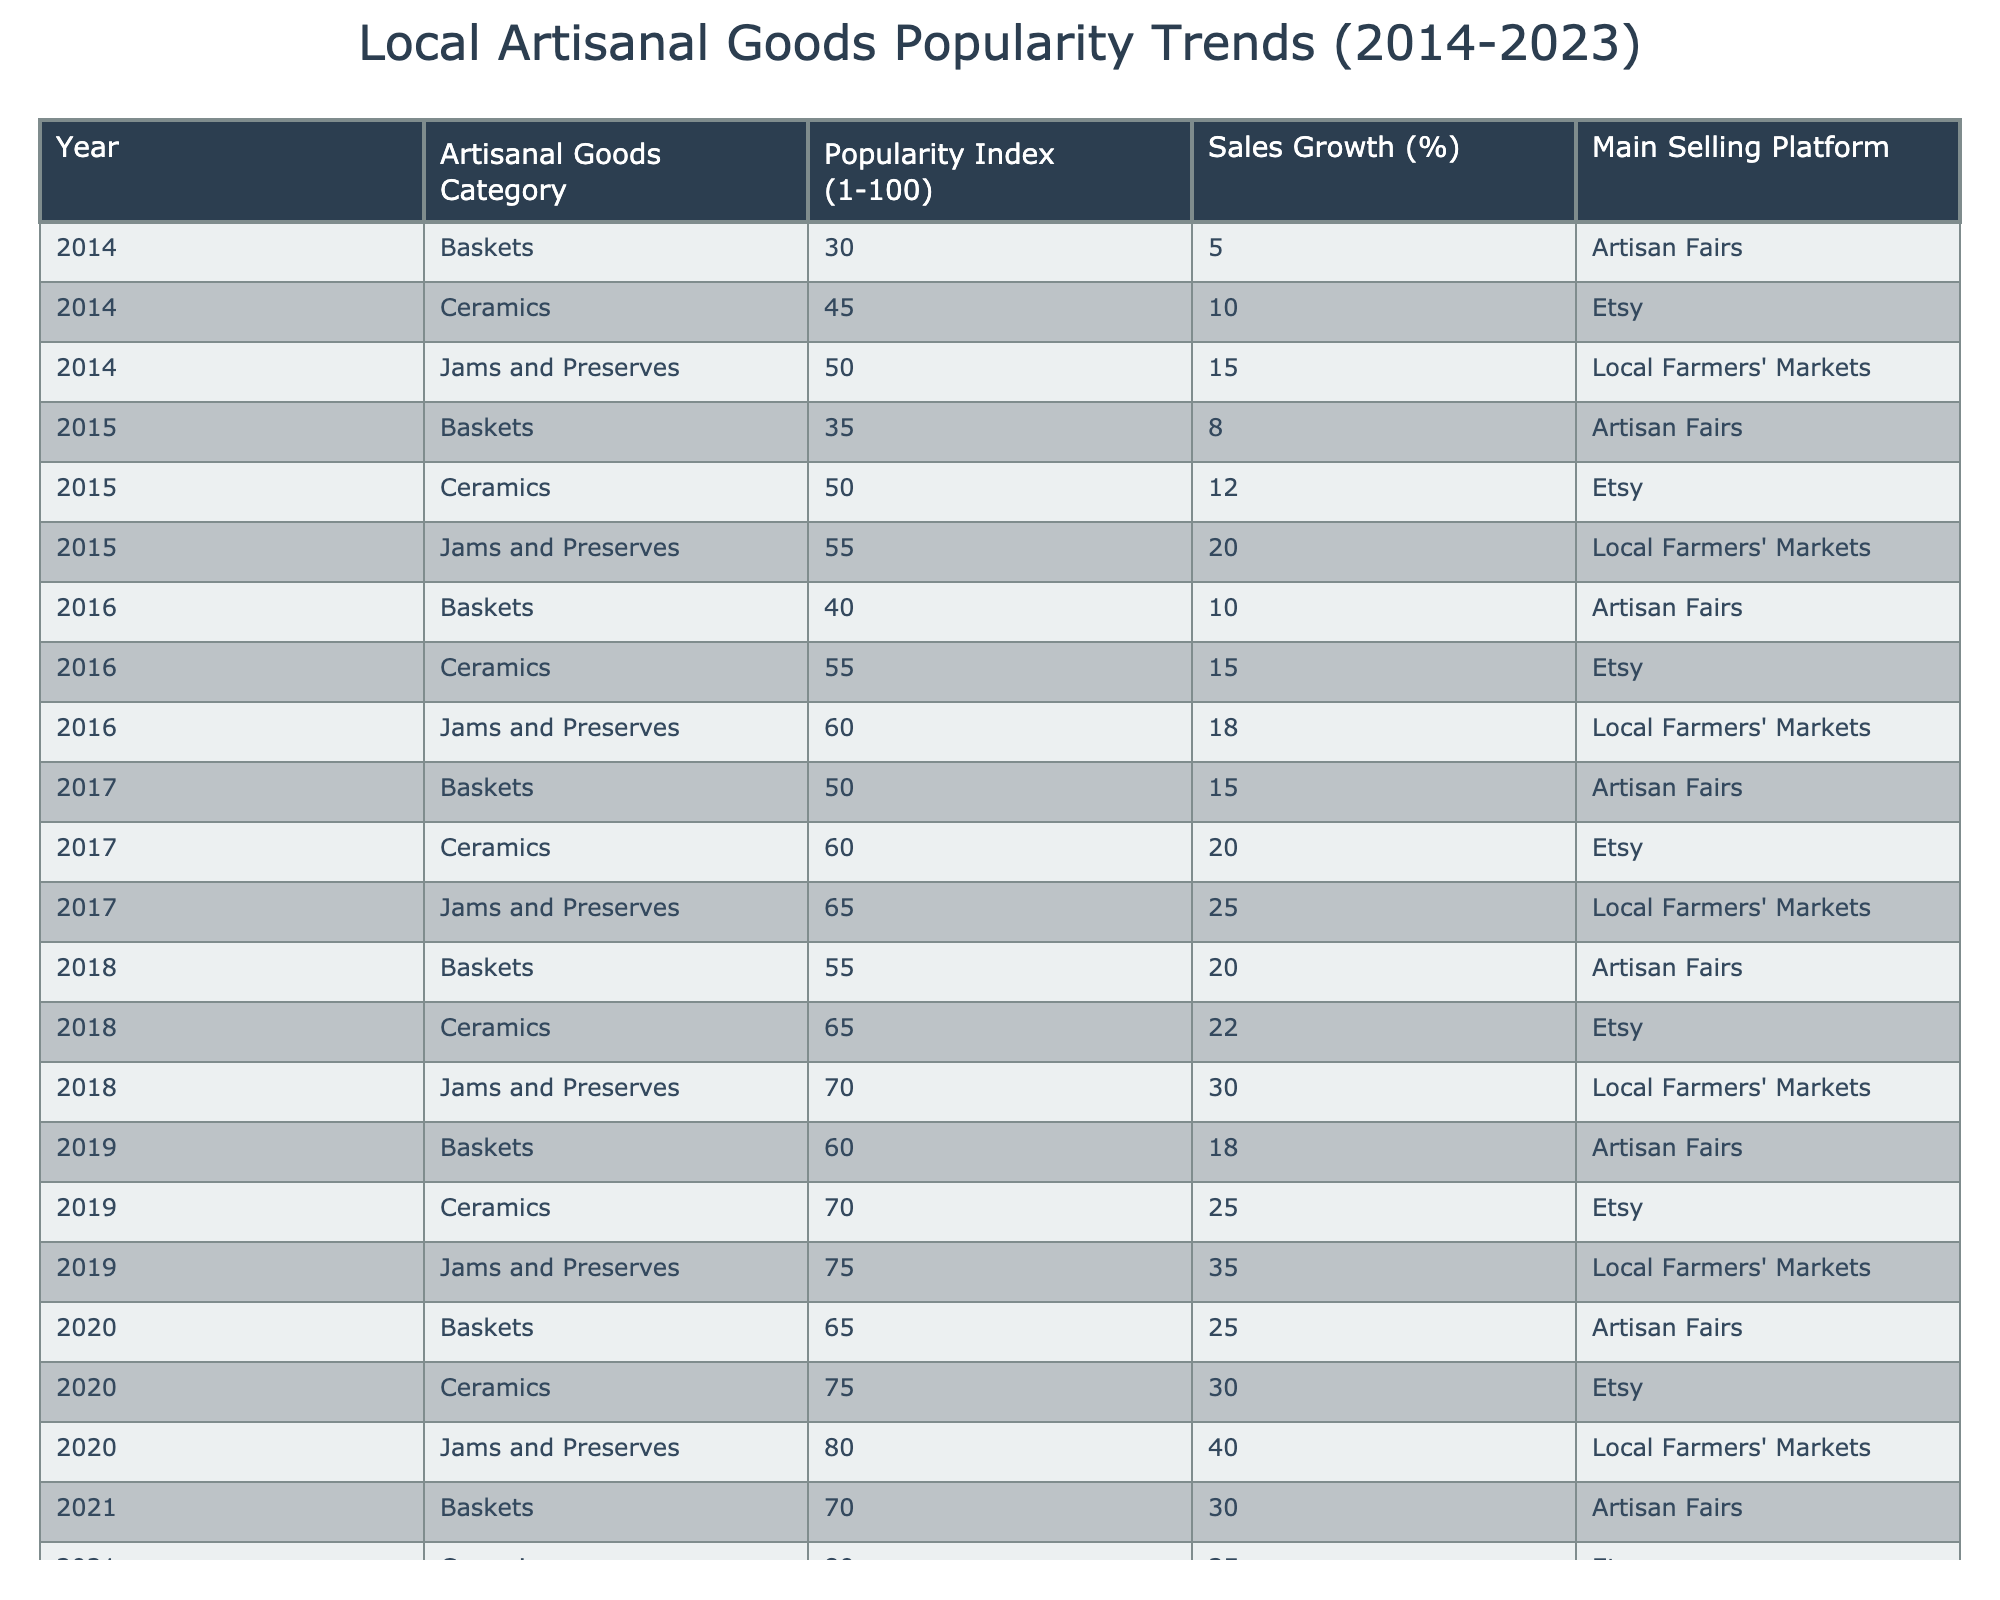What was the popularity index of Jams and Preserves in 2015? Looking at the row for the year 2015 and the category Jams and Preserves, the popularity index is listed as 55.
Answer: 55 What is the sales growth percentage for Baskets in 2022? From the table, the row for 2022 indicates that Baskets had a sales growth percentage of 35%.
Answer: 35 Which artisanal goods category had the highest popularity index in 2023? In 2023, Jams and Preserves has the highest popularity index at 95 compared to Ceramics at 90 and Baskets at 80.
Answer: Jams and Preserves What was the average popularity index for Ceramics from 2014 to 2023? Calculating the average: (45 + 50 + 55 + 60 + 65 + 70 + 75 + 80 + 85 + 90) = 675. There are 10 data points, so the average is 675 / 10 = 67.5.
Answer: 67.5 Did the popularity index for Baskets increase every year from 2014 to 2023? By checking each year, Baskets started at 30 in 2014 and increased to 80 in 2023; thus, the popularity index did increase every year.
Answer: Yes What is the total sales growth percentage for Jams and Preserves from 2014 to 2023? Summing the sales growth percentages: 15 + 20 + 18 + 25 + 30 + 50 + 55 + 60 = 273%.
Answer: 273% In which year did the sales growth percentage for Ceramics surpass 20% for the first time? Looking through the years, Ceramics had a sales growth percentage of 22% for the first time in 2018, which is the first year it exceeded 20%.
Answer: 2018 Was there a year when both Ceramics and Jams and Preserves had their highest popularity index? Yes, in 2023 both Ceramics (90) and Jams and Preserves (95) achieved their highest popularity index at that time.
Answer: Yes What is the difference in popularity index between the highest and lowest performing category in 2014? In 2014, Ceramics had a popularity index of 45 (lowest), and Jams and Preserves had an index of 50 (highest). The difference is 50 - 30 = 20.
Answer: 20 